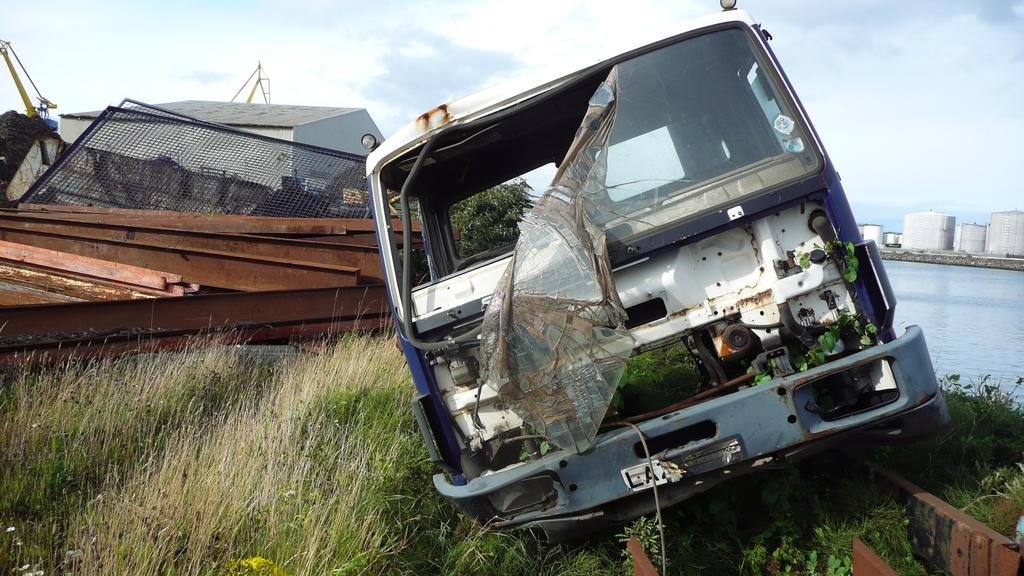What is the main subject of the image? There is a crashed vehicle in the image. What type of terrain is visible in the image? There is grass visible in the image. What can be seen on the ground in the image? There are objects on the ground in the image. What is visible in the background of the image? There are buildings, trees, water, and the sky visible in the background of the image. Can you tell me how many coaches are helping the vehicle in the image? There is no coach present in the image, and no one is helping the vehicle. 